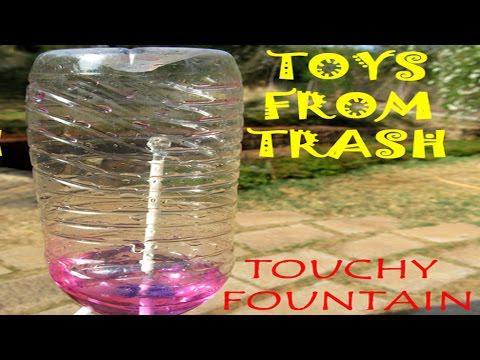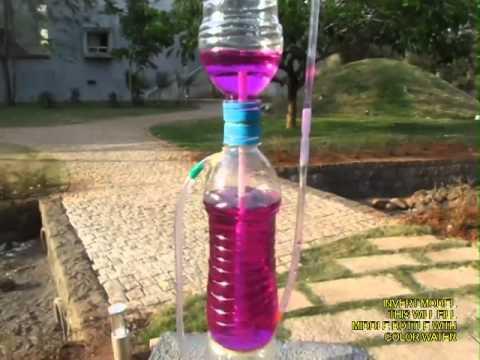The first image is the image on the left, the second image is the image on the right. Examine the images to the left and right. Is the description "Each image shows a set-up with purple liquid flowing from the top to the bottom, with blue bottle caps visible in each picture." accurate? Answer yes or no. No. The first image is the image on the left, the second image is the image on the right. Considering the images on both sides, is "One of the images features a person demonstrating the fountain." valid? Answer yes or no. No. 